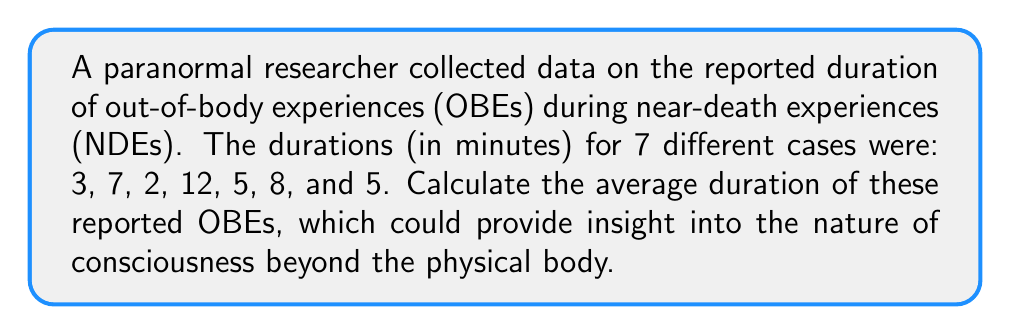Give your solution to this math problem. To calculate the average duration of the reported out-of-body experiences, we need to follow these steps:

1. Sum up all the reported durations:
   $$ 3 + 7 + 2 + 12 + 5 + 8 + 5 = 42 \text{ minutes} $$

2. Count the total number of cases:
   There are 7 cases in total.

3. Calculate the average by dividing the sum by the number of cases:
   $$ \text{Average} = \frac{\text{Sum of durations}}{\text{Number of cases}} $$
   $$ \text{Average} = \frac{42}{7} = 6 \text{ minutes} $$

Therefore, the average duration of the reported out-of-body experiences is 6 minutes.
Answer: 6 minutes 